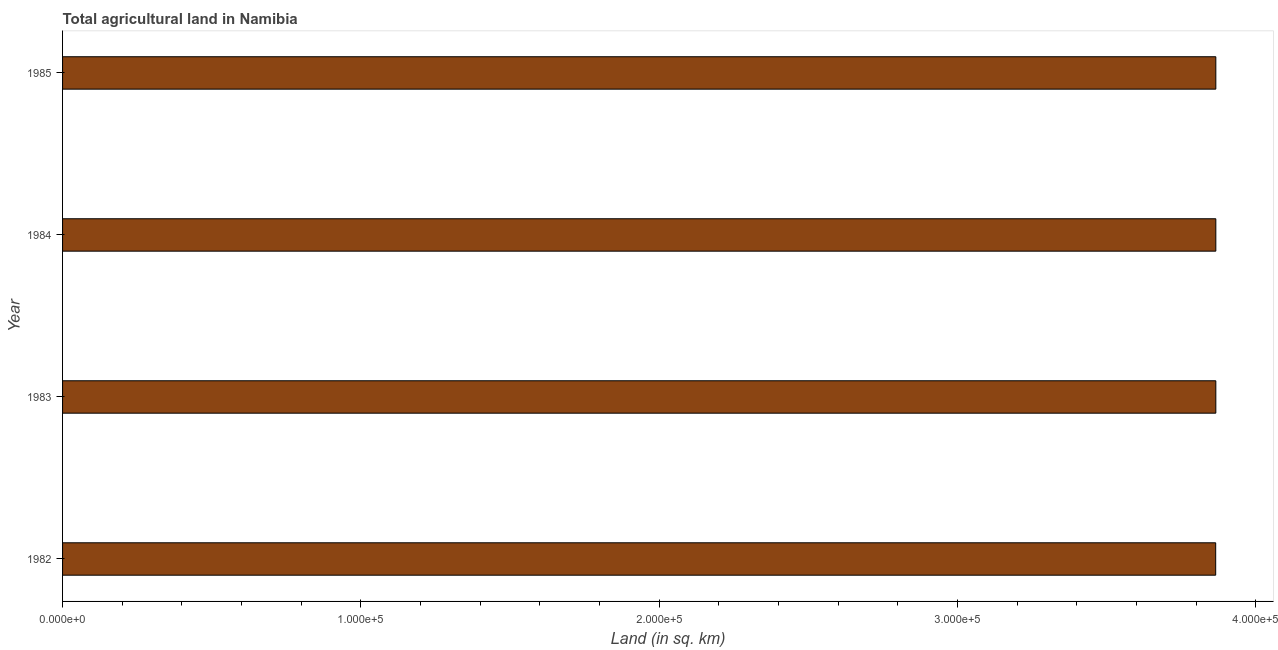Does the graph contain any zero values?
Offer a terse response. No. What is the title of the graph?
Offer a very short reply. Total agricultural land in Namibia. What is the label or title of the X-axis?
Offer a very short reply. Land (in sq. km). What is the agricultural land in 1985?
Provide a short and direct response. 3.87e+05. Across all years, what is the maximum agricultural land?
Make the answer very short. 3.87e+05. Across all years, what is the minimum agricultural land?
Provide a succinct answer. 3.87e+05. What is the sum of the agricultural land?
Your answer should be very brief. 1.55e+06. What is the average agricultural land per year?
Keep it short and to the point. 3.87e+05. What is the median agricultural land?
Ensure brevity in your answer.  3.87e+05. In how many years, is the agricultural land greater than 40000 sq. km?
Make the answer very short. 4. What is the ratio of the agricultural land in 1984 to that in 1985?
Make the answer very short. 1. Is the agricultural land in 1982 less than that in 1984?
Offer a terse response. Yes. Is the difference between the agricultural land in 1983 and 1984 greater than the difference between any two years?
Make the answer very short. No. What is the difference between the highest and the second highest agricultural land?
Your answer should be compact. 0. Is the sum of the agricultural land in 1983 and 1984 greater than the maximum agricultural land across all years?
Your answer should be compact. Yes. In how many years, is the agricultural land greater than the average agricultural land taken over all years?
Offer a very short reply. 3. Are all the bars in the graph horizontal?
Make the answer very short. Yes. What is the difference between two consecutive major ticks on the X-axis?
Ensure brevity in your answer.  1.00e+05. Are the values on the major ticks of X-axis written in scientific E-notation?
Give a very brief answer. Yes. What is the Land (in sq. km) of 1982?
Offer a very short reply. 3.87e+05. What is the Land (in sq. km) of 1983?
Provide a short and direct response. 3.87e+05. What is the Land (in sq. km) in 1984?
Provide a short and direct response. 3.87e+05. What is the Land (in sq. km) in 1985?
Offer a very short reply. 3.87e+05. What is the difference between the Land (in sq. km) in 1982 and 1983?
Your response must be concise. -50. What is the difference between the Land (in sq. km) in 1982 and 1984?
Your answer should be very brief. -50. What is the difference between the Land (in sq. km) in 1982 and 1985?
Provide a succinct answer. -50. What is the ratio of the Land (in sq. km) in 1982 to that in 1984?
Provide a succinct answer. 1. What is the ratio of the Land (in sq. km) in 1983 to that in 1985?
Offer a terse response. 1. What is the ratio of the Land (in sq. km) in 1984 to that in 1985?
Keep it short and to the point. 1. 